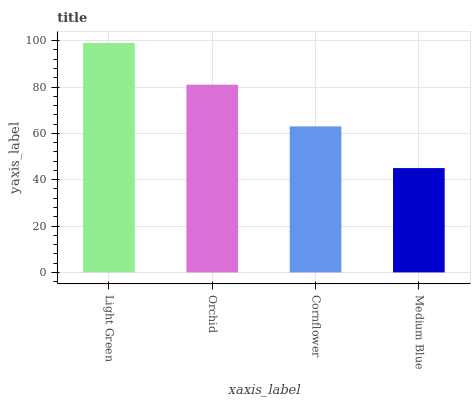Is Medium Blue the minimum?
Answer yes or no. Yes. Is Light Green the maximum?
Answer yes or no. Yes. Is Orchid the minimum?
Answer yes or no. No. Is Orchid the maximum?
Answer yes or no. No. Is Light Green greater than Orchid?
Answer yes or no. Yes. Is Orchid less than Light Green?
Answer yes or no. Yes. Is Orchid greater than Light Green?
Answer yes or no. No. Is Light Green less than Orchid?
Answer yes or no. No. Is Orchid the high median?
Answer yes or no. Yes. Is Cornflower the low median?
Answer yes or no. Yes. Is Cornflower the high median?
Answer yes or no. No. Is Orchid the low median?
Answer yes or no. No. 